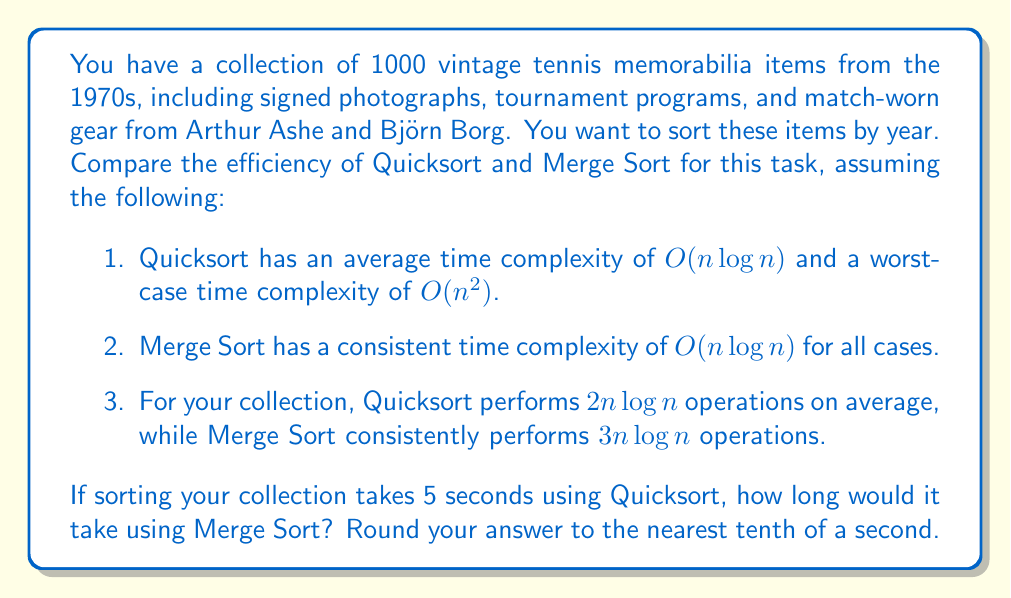Teach me how to tackle this problem. Let's approach this step-by-step:

1) We know that for Quicksort:
   - Time taken = 5 seconds
   - Number of operations = $2n \log n$, where $n = 1000$

2) For Merge Sort:
   - Number of operations = $3n \log n$

3) Let's set up a proportion to find the time for Merge Sort:

   $$\frac{\text{Quicksort time}}{\text{Quicksort operations}} = \frac{\text{Merge Sort time}}{\text{Merge Sort operations}}$$

4) Substituting the values:

   $$\frac{5 \text{ seconds}}{2n \log n} = \frac{x \text{ seconds}}{3n \log n}$$

5) Simplify:

   $$\frac{5}{2} = \frac{x}{3}$$

6) Cross multiply:

   $$5 \cdot 3 = 2x$$

7) Solve for x:

   $$15 = 2x$$
   $$x = \frac{15}{2} = 7.5 \text{ seconds}$$

8) Rounding to the nearest tenth:

   7.5 seconds rounds to 7.5 seconds.
Answer: 7.5 seconds 